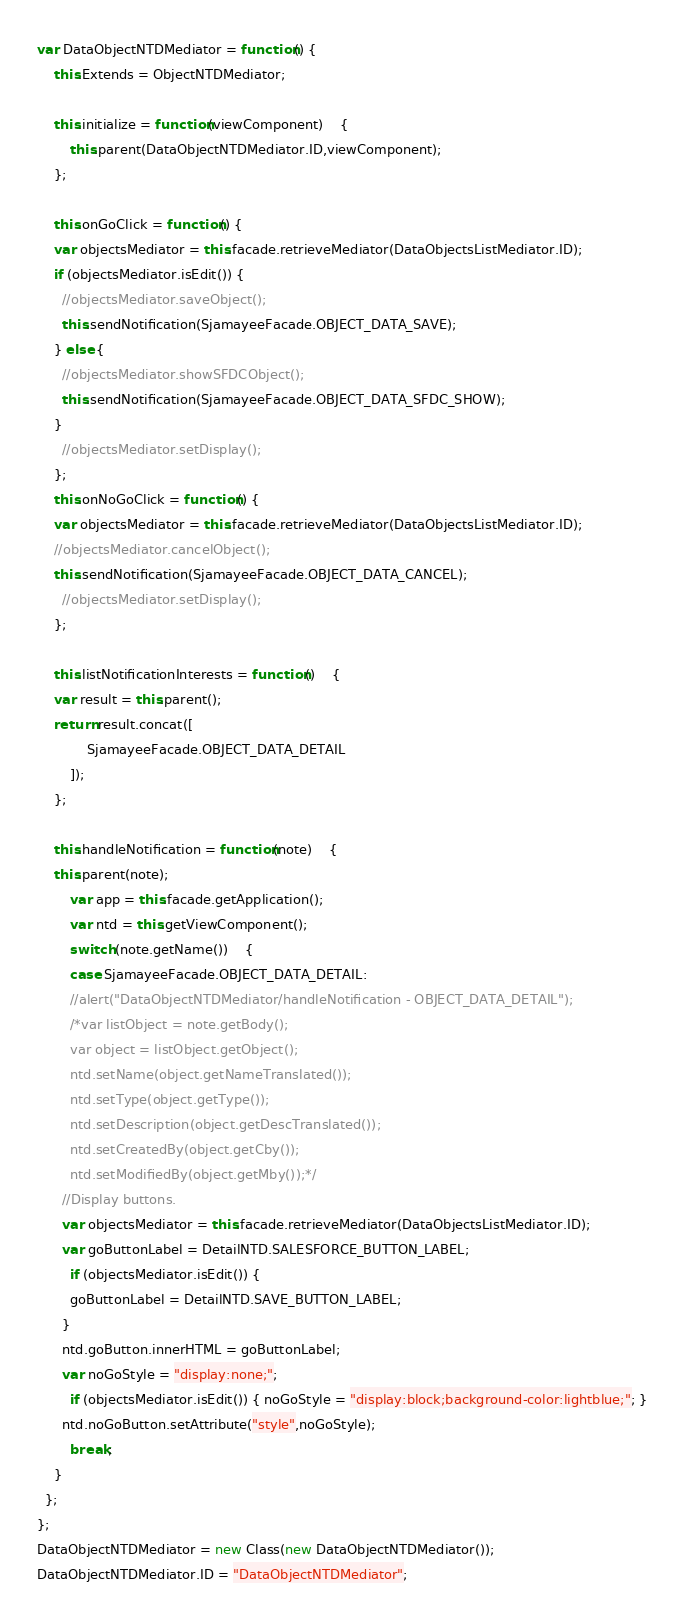Convert code to text. <code><loc_0><loc_0><loc_500><loc_500><_JavaScript_>var DataObjectNTDMediator = function() {
	this.Extends = ObjectNTDMediator;

	this.initialize = function(viewComponent)	{
		this.parent(DataObjectNTDMediator.ID,viewComponent);
	};

	this.onGoClick = function() {
    var objectsMediator = this.facade.retrieveMediator(DataObjectsListMediator.ID);
    if (objectsMediator.isEdit()) {
      //objectsMediator.saveObject();
      this.sendNotification(SjamayeeFacade.OBJECT_DATA_SAVE);
    } else {
      //objectsMediator.showSFDCObject();
      this.sendNotification(SjamayeeFacade.OBJECT_DATA_SFDC_SHOW);
    }
	  //objectsMediator.setDisplay();
	};
	this.onNoGoClick = function() {
    var objectsMediator = this.facade.retrieveMediator(DataObjectsListMediator.ID);
    //objectsMediator.cancelObject();
    this.sendNotification(SjamayeeFacade.OBJECT_DATA_CANCEL);
	  //objectsMediator.setDisplay();
	};

	this.listNotificationInterests = function()	{
    var result = this.parent();
    return result.concat([
			SjamayeeFacade.OBJECT_DATA_DETAIL
		]);
	};

	this.handleNotification = function(note)	{
    this.parent(note);
		var app = this.facade.getApplication();
		var ntd = this.getViewComponent();
		switch (note.getName())	{
    	case SjamayeeFacade.OBJECT_DATA_DETAIL:
    	//alert("DataObjectNTDMediator/handleNotification - OBJECT_DATA_DETAIL");
    	/*var listObject = note.getBody();
    	var object = listObject.getObject();
    	ntd.setName(object.getNameTranslated());
    	ntd.setType(object.getType());
    	ntd.setDescription(object.getDescTranslated());
    	ntd.setCreatedBy(object.getCby());
    	ntd.setModifiedBy(object.getMby());*/
      //Display buttons.
      var objectsMediator = this.facade.retrieveMediator(DataObjectsListMediator.ID);
      var goButtonLabel = DetailNTD.SALESFORCE_BUTTON_LABEL;
    	if (objectsMediator.isEdit()) {
      	goButtonLabel = DetailNTD.SAVE_BUTTON_LABEL;
      }
      ntd.goButton.innerHTML = goButtonLabel;
      var noGoStyle = "display:none;";
    	if (objectsMediator.isEdit()) { noGoStyle = "display:block;background-color:lightblue;"; }
      ntd.noGoButton.setAttribute("style",noGoStyle);
    	break;
    }
  };
};
DataObjectNTDMediator = new Class(new DataObjectNTDMediator());
DataObjectNTDMediator.ID = "DataObjectNTDMediator";
</code> 